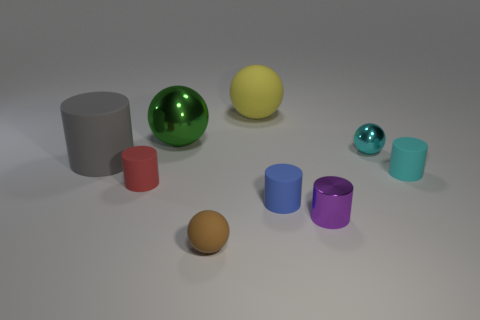The large cylinder has what color?
Offer a very short reply. Gray. There is a large gray matte object that is on the left side of the small object that is on the left side of the sphere in front of the blue matte thing; what shape is it?
Make the answer very short. Cylinder. What material is the ball that is in front of the tiny cyan thing that is behind the small cyan rubber cylinder made of?
Make the answer very short. Rubber. What is the shape of the tiny cyan thing that is the same material as the brown thing?
Your answer should be compact. Cylinder. Is there anything else that is the same shape as the purple thing?
Give a very brief answer. Yes. There is a large green object; how many tiny cylinders are behind it?
Offer a terse response. 0. Are any large cylinders visible?
Offer a very short reply. Yes. The big ball that is to the left of the large yellow matte thing that is right of the big metal sphere that is to the right of the large gray matte cylinder is what color?
Your response must be concise. Green. There is a tiny ball that is behind the gray cylinder; are there any tiny brown rubber spheres that are to the right of it?
Give a very brief answer. No. Is the color of the small thing behind the large gray rubber cylinder the same as the large thing in front of the cyan metallic sphere?
Give a very brief answer. No. 